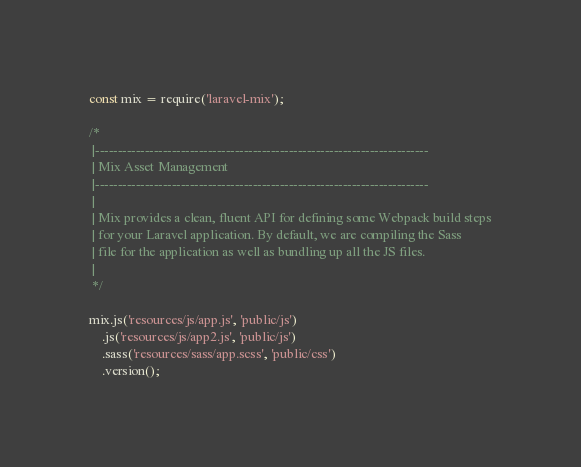<code> <loc_0><loc_0><loc_500><loc_500><_JavaScript_>const mix = require('laravel-mix');

/*
 |--------------------------------------------------------------------------
 | Mix Asset Management
 |--------------------------------------------------------------------------
 |
 | Mix provides a clean, fluent API for defining some Webpack build steps
 | for your Laravel application. By default, we are compiling the Sass
 | file for the application as well as bundling up all the JS files.
 |
 */

mix.js('resources/js/app.js', 'public/js')
    .js('resources/js/app2.js', 'public/js')
    .sass('resources/sass/app.scss', 'public/css')
    .version();
</code> 